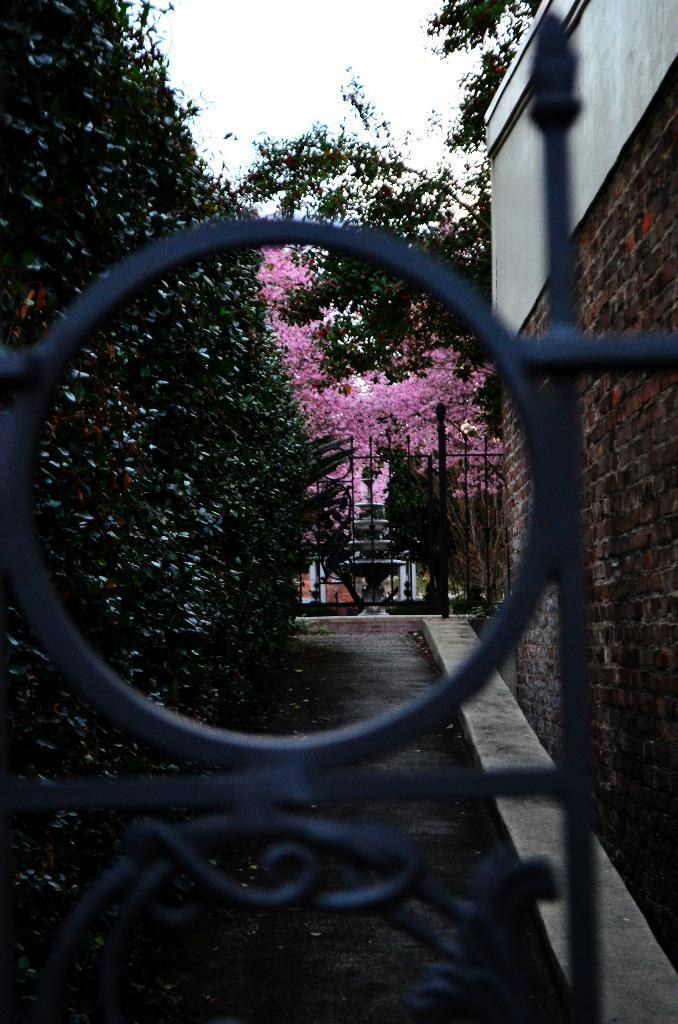Can you describe this image briefly? In the image we can see there is a gate and there are plants on the wall. There are flowers on the plant and there is a wall made up of bricks. 